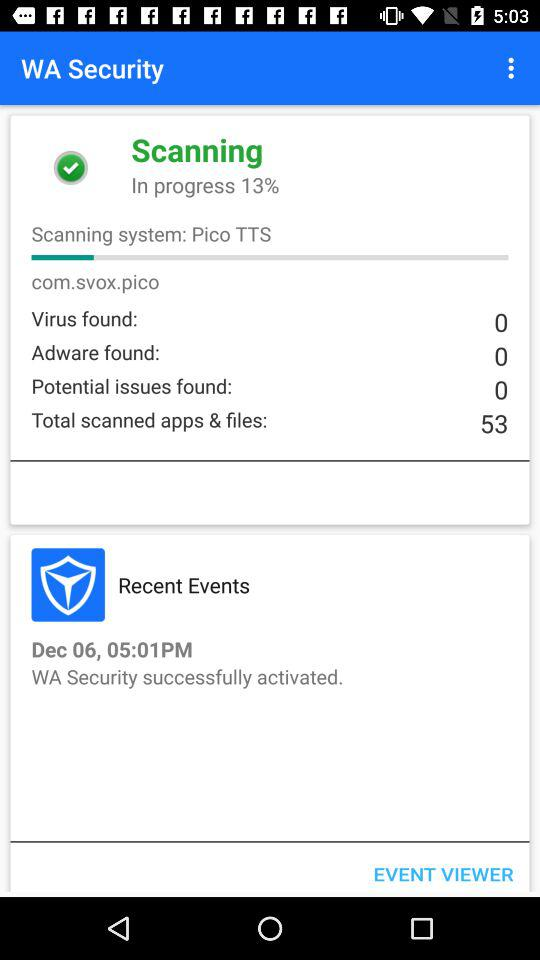What is the time of the "Recent Events"? The time is 05:01 PM. 